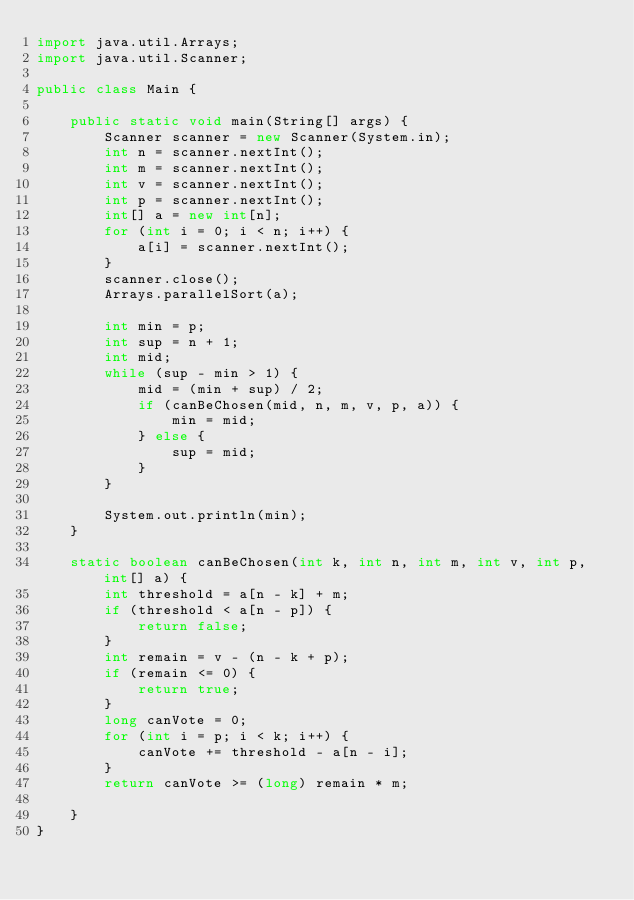Convert code to text. <code><loc_0><loc_0><loc_500><loc_500><_Java_>import java.util.Arrays;
import java.util.Scanner;

public class Main {

	public static void main(String[] args) {
		Scanner scanner = new Scanner(System.in);
		int n = scanner.nextInt();
		int m = scanner.nextInt();
		int v = scanner.nextInt();
		int p = scanner.nextInt();
		int[] a = new int[n];
		for (int i = 0; i < n; i++) {
			a[i] = scanner.nextInt();
		}
		scanner.close();
		Arrays.parallelSort(a);

		int min = p;
		int sup = n + 1;
		int mid;
		while (sup - min > 1) {
			mid = (min + sup) / 2;
			if (canBeChosen(mid, n, m, v, p, a)) {
				min = mid;
			} else {
				sup = mid;
			}
		}

		System.out.println(min);
	}

	static boolean canBeChosen(int k, int n, int m, int v, int p, int[] a) {
		int threshold = a[n - k] + m;
		if (threshold < a[n - p]) {
			return false;
		}
		int remain = v - (n - k + p);
		if (remain <= 0) {
			return true;
		}
		long canVote = 0;
		for (int i = p; i < k; i++) {
			canVote += threshold - a[n - i];
		}
		return canVote >= (long) remain * m;

	}
}
</code> 